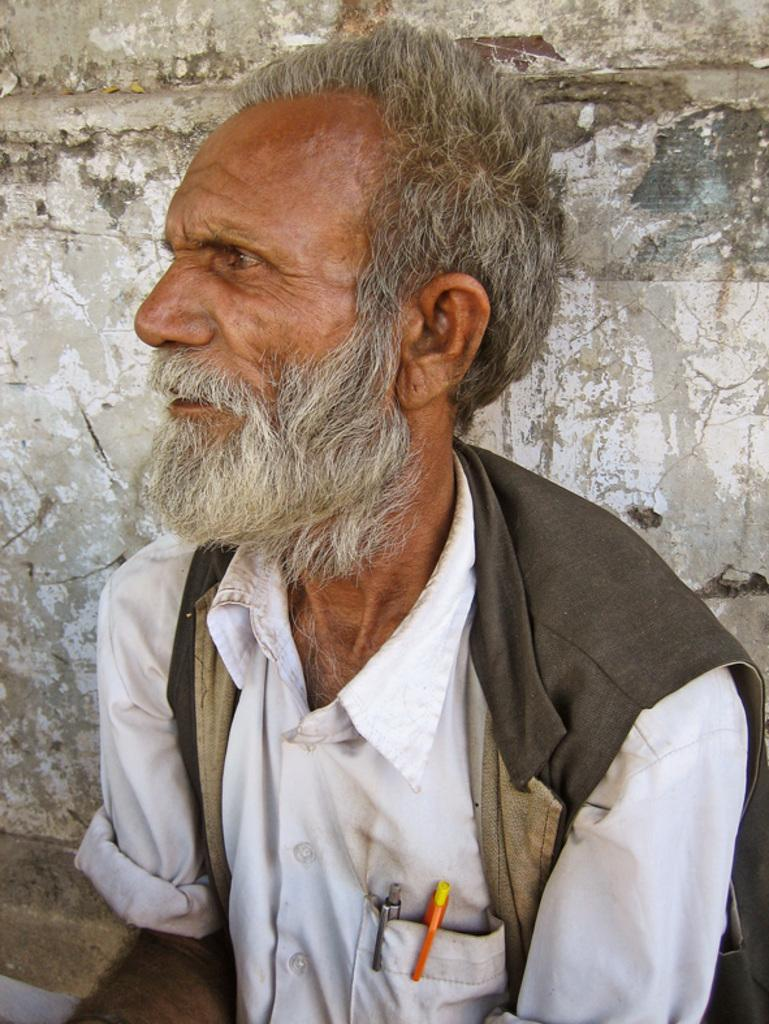Who is the main subject in the image? There is an old man in the image. What is the old man wearing on his upper body? The old man is wearing a white color shirt and a grey color coat. What can be seen in the background of the image? There is a wall in the background of the image. What team does the old man support, as seen in the image? There is no indication in the image of the old man supporting any team. 